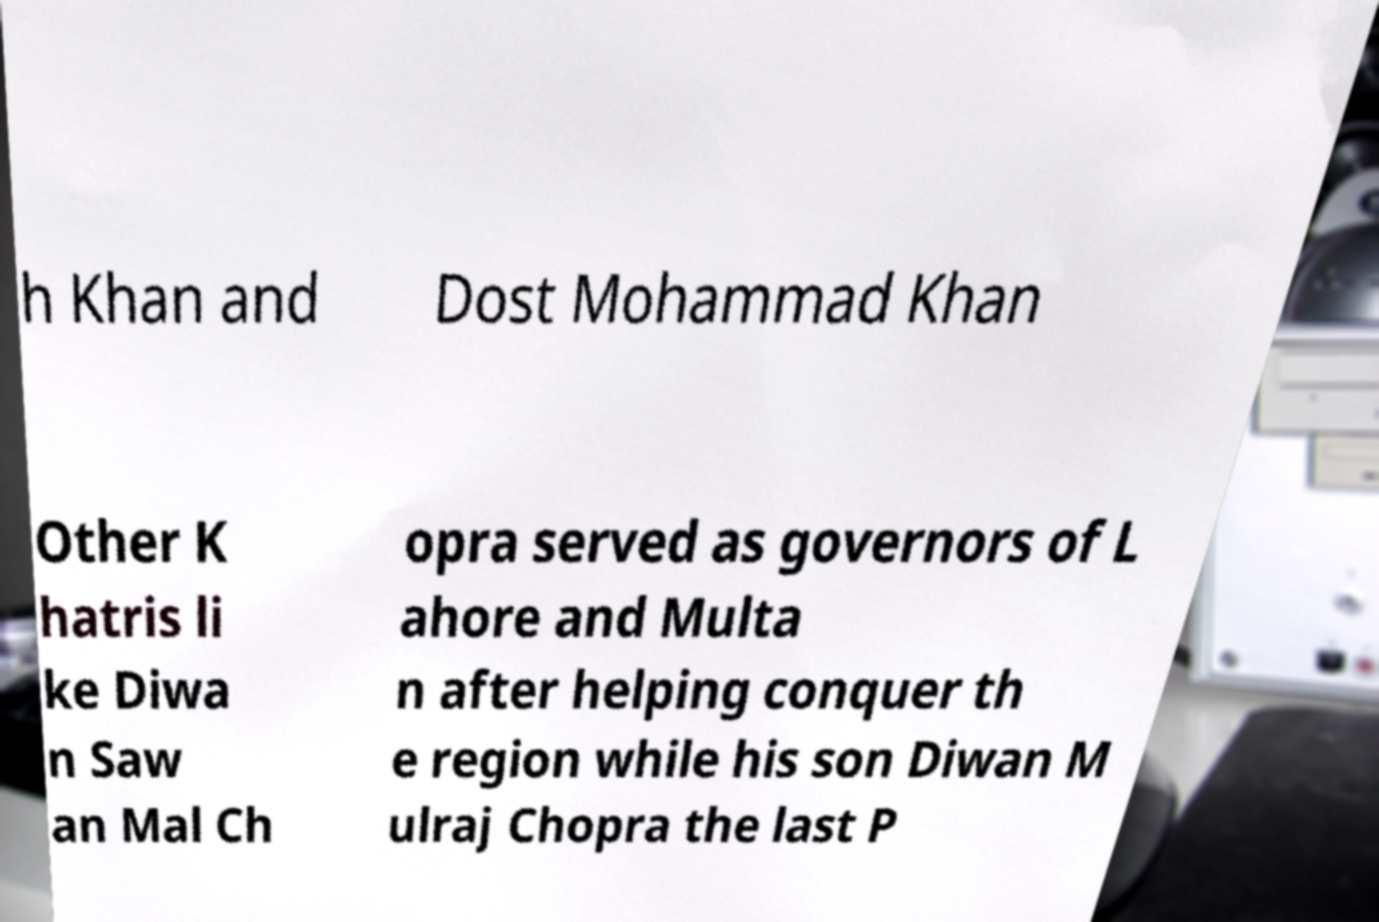There's text embedded in this image that I need extracted. Can you transcribe it verbatim? h Khan and Dost Mohammad Khan Other K hatris li ke Diwa n Saw an Mal Ch opra served as governors of L ahore and Multa n after helping conquer th e region while his son Diwan M ulraj Chopra the last P 